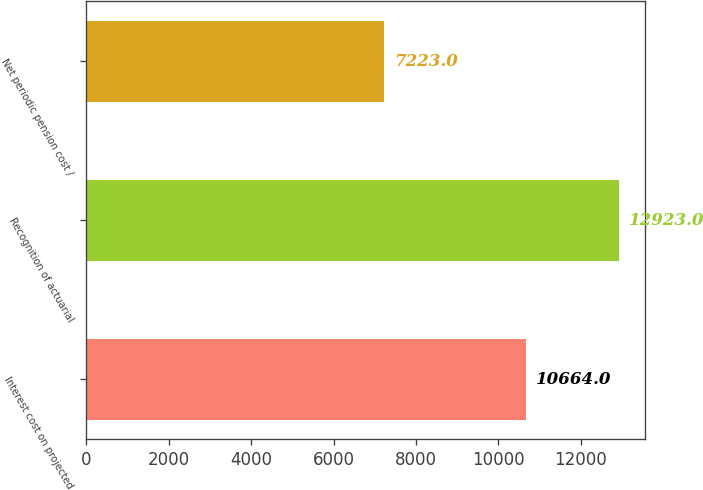<chart> <loc_0><loc_0><loc_500><loc_500><bar_chart><fcel>Interest cost on projected<fcel>Recognition of actuarial<fcel>Net periodic pension cost /<nl><fcel>10664<fcel>12923<fcel>7223<nl></chart> 